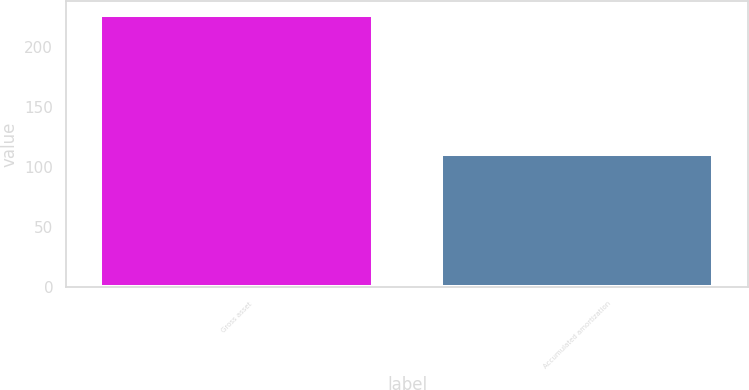<chart> <loc_0><loc_0><loc_500><loc_500><bar_chart><fcel>Gross asset<fcel>Accumulated amortization<nl><fcel>227<fcel>111<nl></chart> 